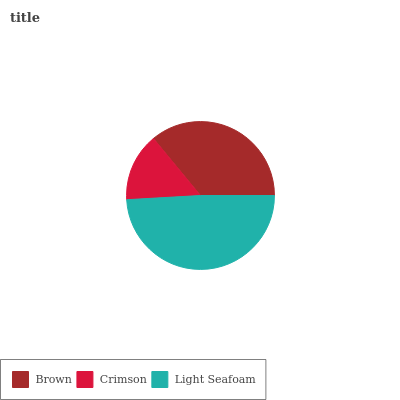Is Crimson the minimum?
Answer yes or no. Yes. Is Light Seafoam the maximum?
Answer yes or no. Yes. Is Light Seafoam the minimum?
Answer yes or no. No. Is Crimson the maximum?
Answer yes or no. No. Is Light Seafoam greater than Crimson?
Answer yes or no. Yes. Is Crimson less than Light Seafoam?
Answer yes or no. Yes. Is Crimson greater than Light Seafoam?
Answer yes or no. No. Is Light Seafoam less than Crimson?
Answer yes or no. No. Is Brown the high median?
Answer yes or no. Yes. Is Brown the low median?
Answer yes or no. Yes. Is Light Seafoam the high median?
Answer yes or no. No. Is Light Seafoam the low median?
Answer yes or no. No. 